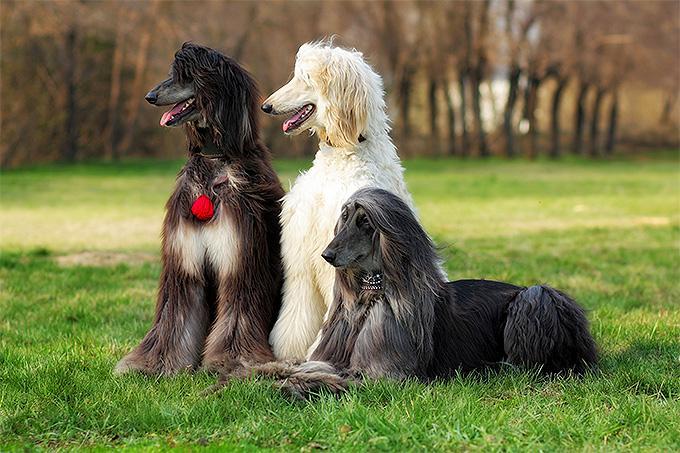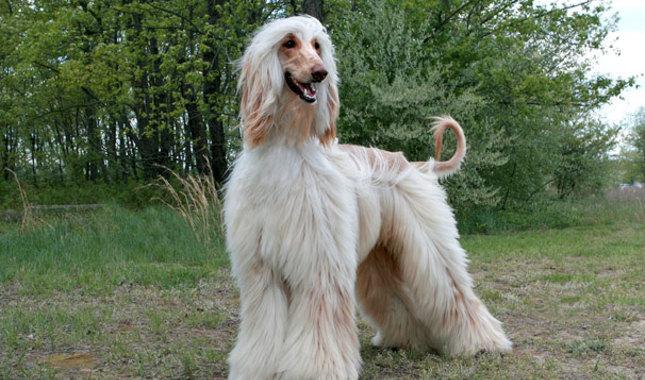The first image is the image on the left, the second image is the image on the right. Evaluate the accuracy of this statement regarding the images: "In one of the images, there is at least one dog sitting down". Is it true? Answer yes or no. Yes. 